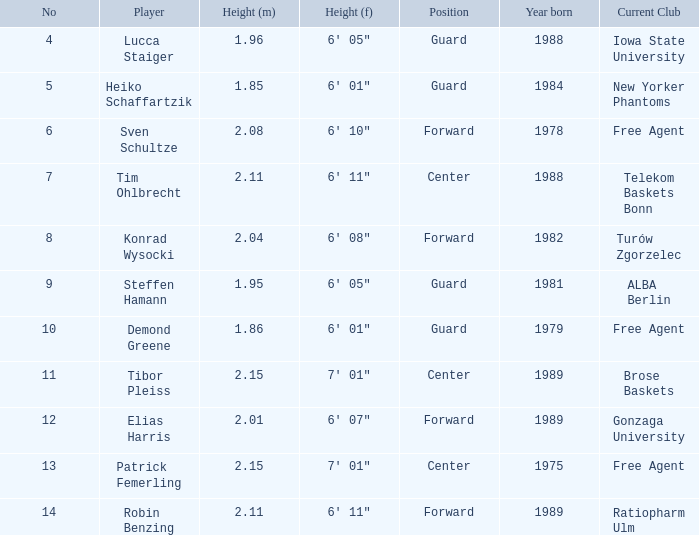85 m? Heiko Schaffartzik. 